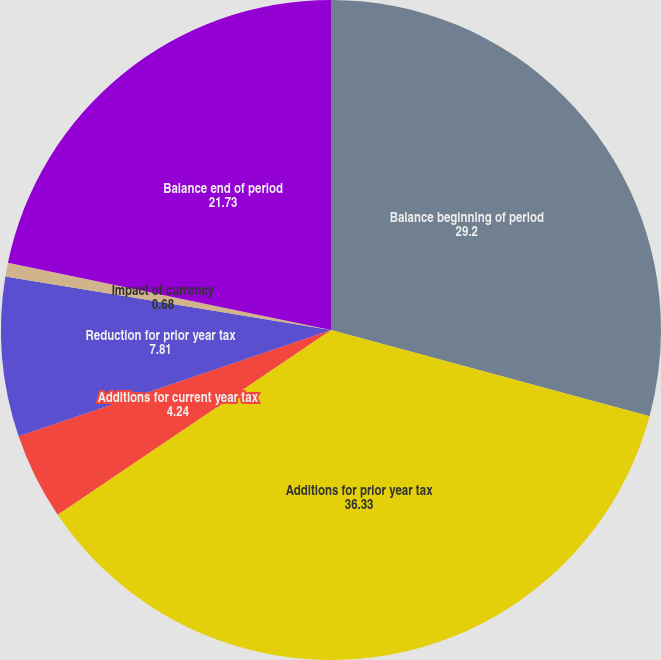<chart> <loc_0><loc_0><loc_500><loc_500><pie_chart><fcel>Balance beginning of period<fcel>Additions for prior year tax<fcel>Additions for current year tax<fcel>Reduction for prior year tax<fcel>Impact of currency<fcel>Balance end of period<nl><fcel>29.2%<fcel>36.33%<fcel>4.24%<fcel>7.81%<fcel>0.68%<fcel>21.73%<nl></chart> 